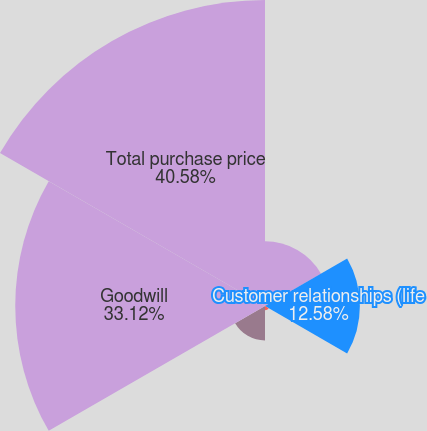Convert chart to OTSL. <chart><loc_0><loc_0><loc_500><loc_500><pie_chart><fcel>Book value of minority<fcel>Customer relationships (life<fcel>Other identifiable intangible<fcel>Deferred income taxes<fcel>Goodwill<fcel>Total purchase price<nl><fcel>8.58%<fcel>12.58%<fcel>0.57%<fcel>4.57%<fcel>33.12%<fcel>40.58%<nl></chart> 